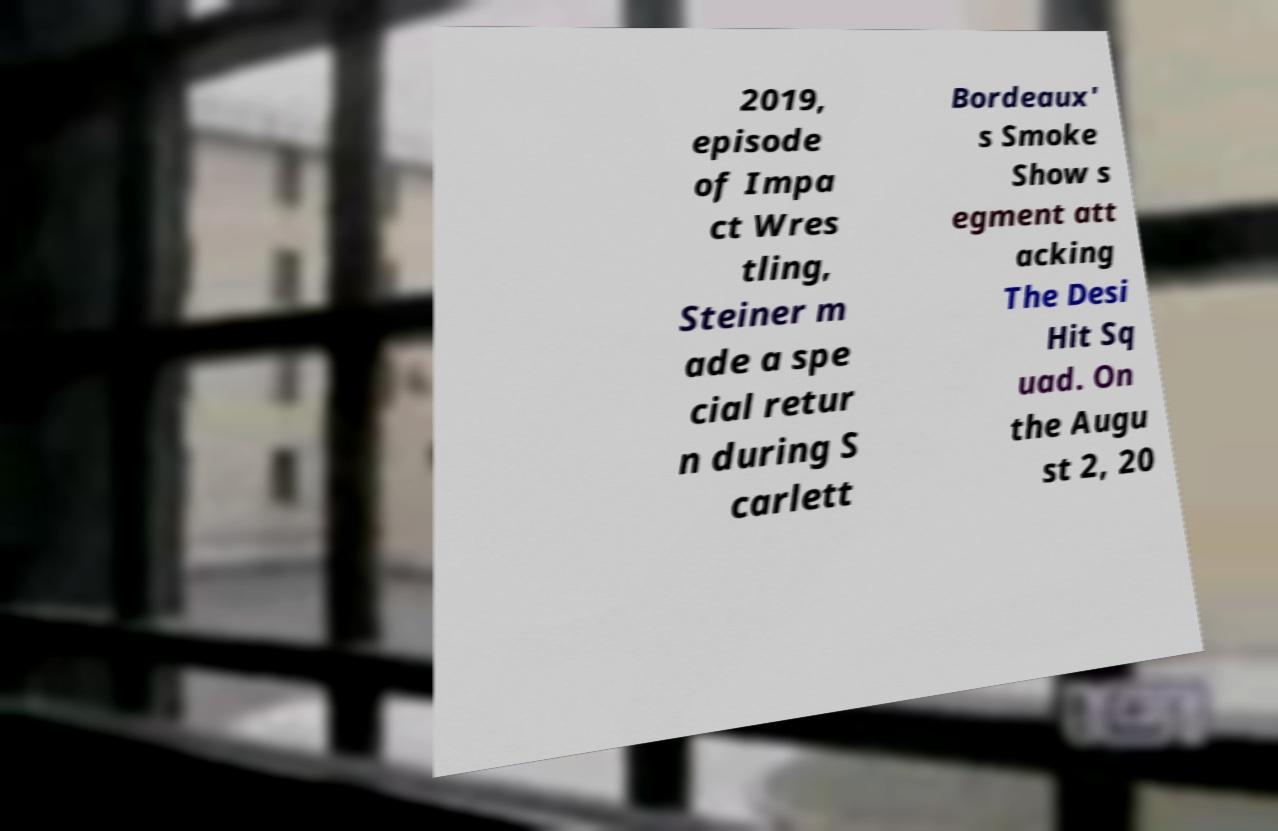Could you extract and type out the text from this image? 2019, episode of Impa ct Wres tling, Steiner m ade a spe cial retur n during S carlett Bordeaux' s Smoke Show s egment att acking The Desi Hit Sq uad. On the Augu st 2, 20 